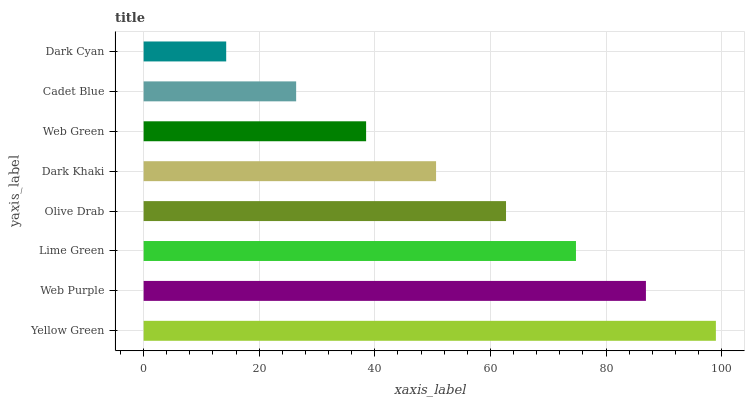Is Dark Cyan the minimum?
Answer yes or no. Yes. Is Yellow Green the maximum?
Answer yes or no. Yes. Is Web Purple the minimum?
Answer yes or no. No. Is Web Purple the maximum?
Answer yes or no. No. Is Yellow Green greater than Web Purple?
Answer yes or no. Yes. Is Web Purple less than Yellow Green?
Answer yes or no. Yes. Is Web Purple greater than Yellow Green?
Answer yes or no. No. Is Yellow Green less than Web Purple?
Answer yes or no. No. Is Olive Drab the high median?
Answer yes or no. Yes. Is Dark Khaki the low median?
Answer yes or no. Yes. Is Lime Green the high median?
Answer yes or no. No. Is Web Green the low median?
Answer yes or no. No. 